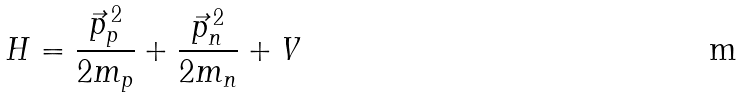Convert formula to latex. <formula><loc_0><loc_0><loc_500><loc_500>H = \frac { \vec { p } _ { p } ^ { \, 2 } } { 2 m _ { p } } + \frac { \vec { p } _ { n } ^ { \, 2 } } { 2 m _ { n } } + V</formula> 